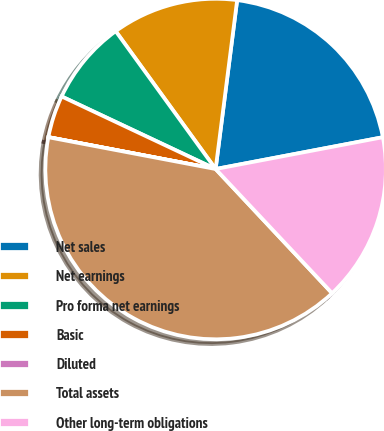Convert chart. <chart><loc_0><loc_0><loc_500><loc_500><pie_chart><fcel>Net sales<fcel>Net earnings<fcel>Pro forma net earnings<fcel>Basic<fcel>Diluted<fcel>Total assets<fcel>Other long-term obligations<nl><fcel>19.99%<fcel>12.0%<fcel>8.01%<fcel>4.01%<fcel>0.01%<fcel>39.98%<fcel>16.0%<nl></chart> 